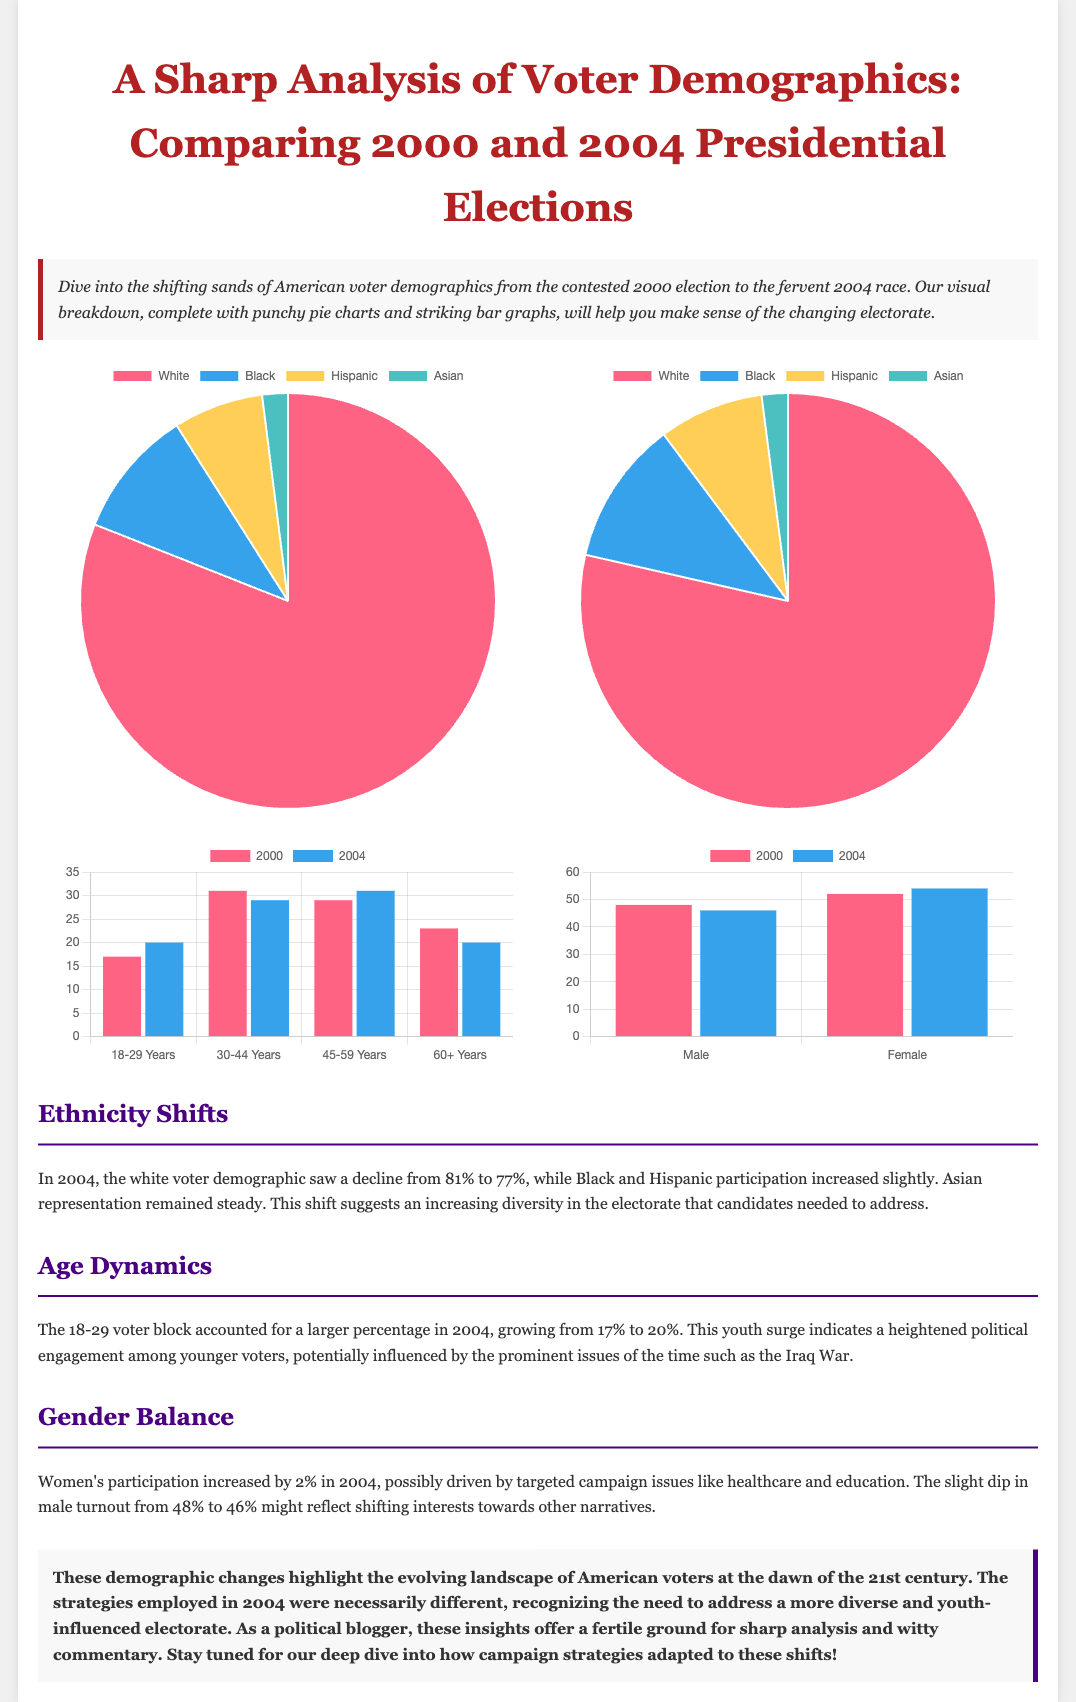what was the percentage of white voters in 2000? The percentage of white voters in 2000 is explicitly stated in the pie chart for that year.
Answer: 81% what was the percentage of female voters in 2004? The percentage of female voters in 2004 can be found in the gender distribution bar graph.
Answer: 54% which age group had the largest percentage of voters in 2000? The age group with the largest percentage of voters in 2000 is detailed in the age group comparison bar graph.
Answer: 30-44 Years by how much did the 18-29 age group increase from 2000 to 2004? The increase in the 18-29 age group is calculated by subtracting the percentage in 2000 from the percentage in 2004 as shown in the bar graph.
Answer: 3% what is the primary color representing the demographic of Black voters in the pie chart? The primary color for the Black voter demographic is specified in the color assignment within the pie charts.
Answer: Blue why did women’s participation increase in 2004 based on the document's analysis? The document attributes the increase in women's participation to specific campaign issues that resonated with them in 2004.
Answer: Health care and education what trend is observed regarding the Hispanic voter percentage from 2000 to 2004? The trend is identified by reviewing the pie charts and comparing the percentages of Hispanic voters in both years.
Answer: Increased slightly what conclusion does the document draw about voter demographics in the 2004 election? The conclusion summarizes the evolving voter demographics and how they impacted campaign strategies, which is directly expressed in the text.
Answer: More diverse and youth-influenced electorate 